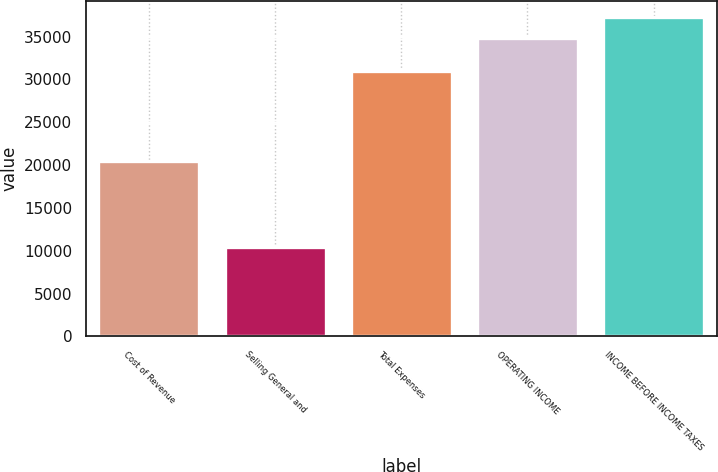<chart> <loc_0><loc_0><loc_500><loc_500><bar_chart><fcel>Cost of Revenue<fcel>Selling General and<fcel>Total Expenses<fcel>OPERATING INCOME<fcel>INCOME BEFORE INCOME TAXES<nl><fcel>20504<fcel>10436<fcel>30940<fcel>34866<fcel>37309<nl></chart> 